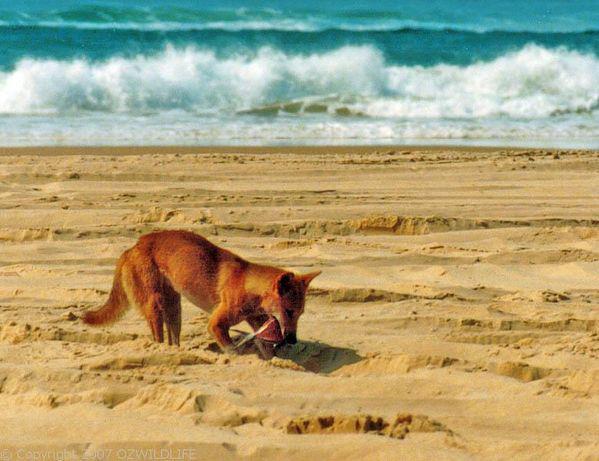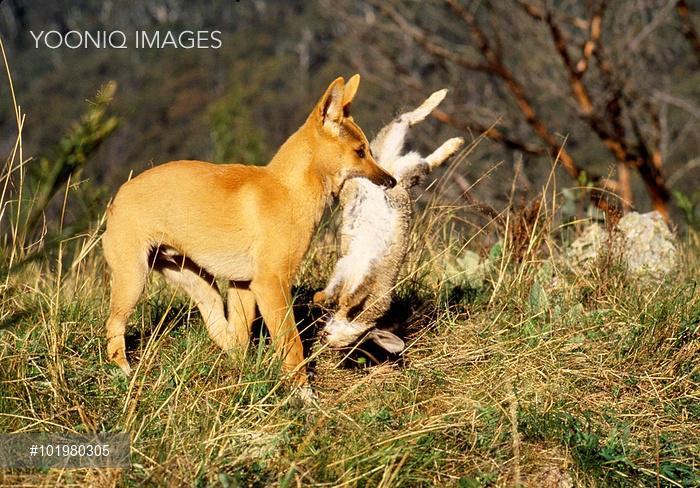The first image is the image on the left, the second image is the image on the right. Assess this claim about the two images: "One of the dingo images includes a natural body of water, and the other features a dog standing upright in the foreground.". Correct or not? Answer yes or no. Yes. The first image is the image on the left, the second image is the image on the right. Considering the images on both sides, is "The right image shows at least one wild dog with a prey in its mouth." valid? Answer yes or no. Yes. 